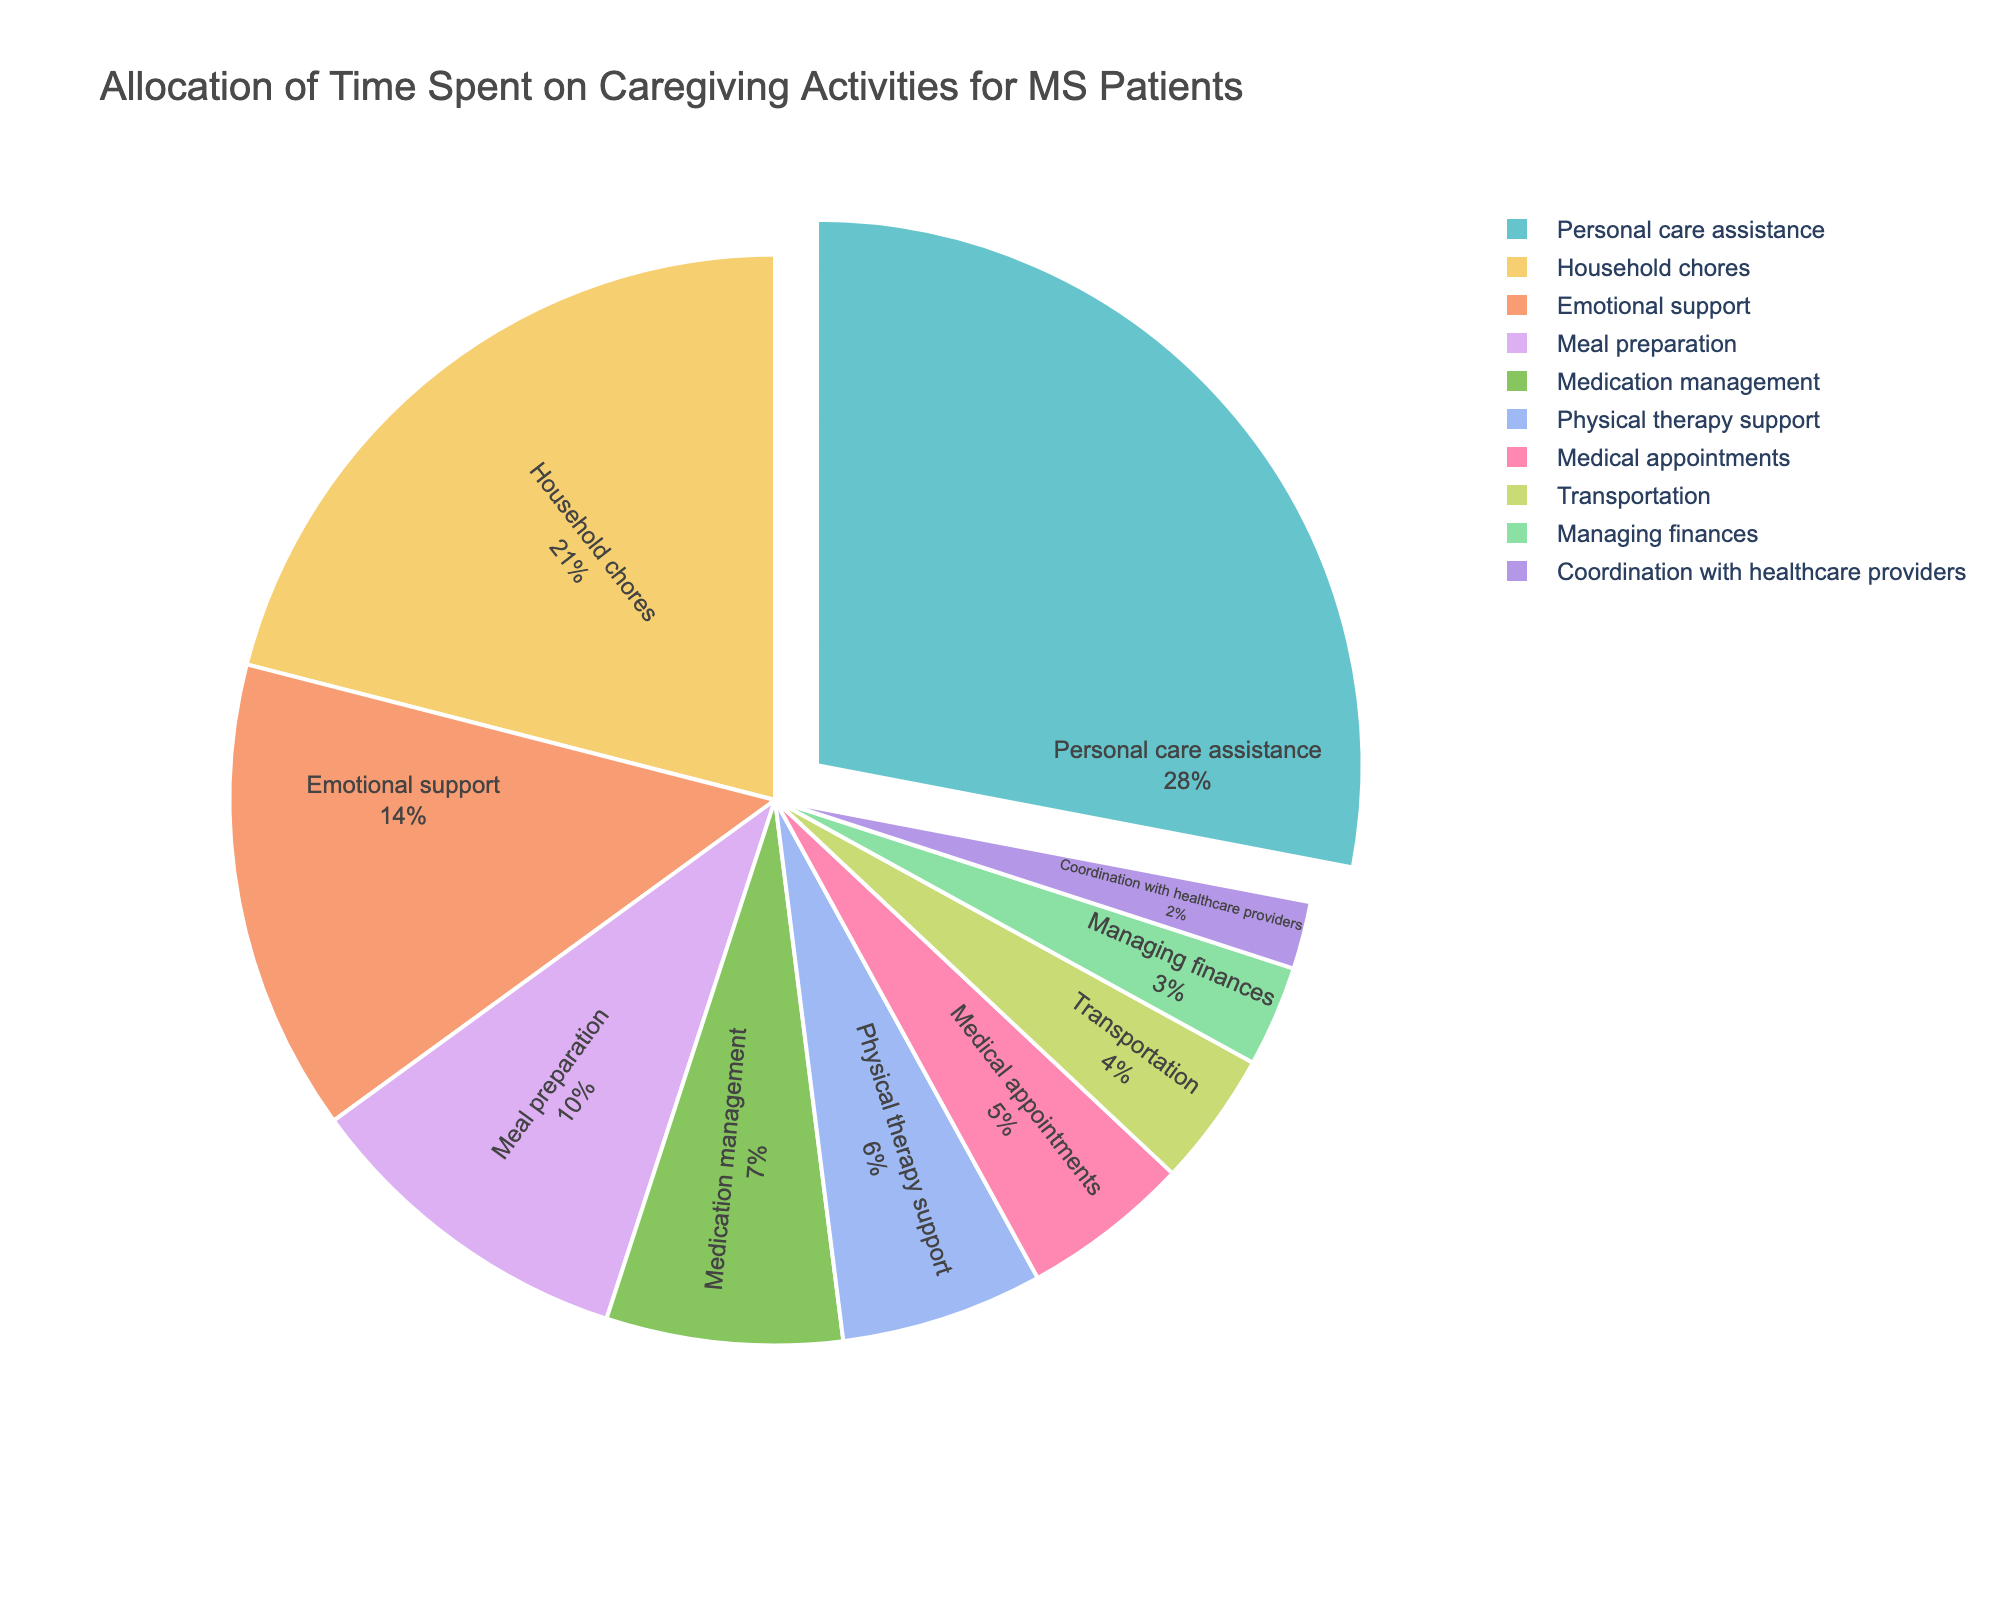what is the total amount of time spent on physical therapy support and meal preparation combined? To find the total time spent, sum up the hours allocated to physical therapy support and meal preparation. Physical therapy support is 6 hours per week and meal preparation is 10 hours per week. So, 6 + 10 = 16 hours per week.
Answer: 16 hours per week Which activity takes up the largest portion of time? From the pie chart, personal care assistance has the largest portion of the pie, highlighted by being pulled out slightly from the rest of the pie chart for emphasis.
Answer: Personal care assistance How much more time is spent on household chores compared to transportation per week? Find the difference in hours between household chores and transportation. Household chores take 21 hours, and transportation takes 4 hours. So, 21 - 4 = 17 hours.
Answer: 17 hours Which caregiving activity occupies the smallest slice of the pie chart? By looking at the pie chart, the smallest slice is for coordination with healthcare providers, which has the fewest hours allocated at 2 hours per week.
Answer: Coordination with healthcare providers Is the time spent on emotional support greater than the time spent on medical appointments and managing finances combined? First, calculate the combined time for medical appointments and managing finances: 5 + 3 = 8 hours. Emotional support takes 14 hours. Since 14 is greater than 8, the time spent on emotional support is indeed greater.
Answer: Yes How many hours per week in total are devoted to meal preparation and medication management? Add the hours for meal preparation (10 hours) to the hours for medication management (7 hours). So, 10 + 7 = 17 hours per week.
Answer: 17 hours per week Which activities collectively account for half of the total caregiving time? Find activities whose combined hours sum up to half of the total caregiving time. The total caregiving time is 100 hours per week (sum of all hours). Half of this is 50 hours. Personal care assistance (28 hours), household chores (21 hours), and transportation (4 hours) together make 53 hours, which is the closest to 50 but slightly more. Thus, the activities could be grouped differently depending on slight adjustments.
Answer: Various combinations How much more time does personal care assistance take compared to medication management? Calculate the difference between the hours spent on personal care assistance and medication management: 28 hours - 7 hours = 21 hours.
Answer: 21 hours What's the total weekly caregiving time? Sum all the hours allocated to each caregiving activity: 28 + 7 + 6 + 14 + 21 + 5 + 10 + 4 + 3 + 2 = 100 hours per week.
Answer: 100 hours per week 